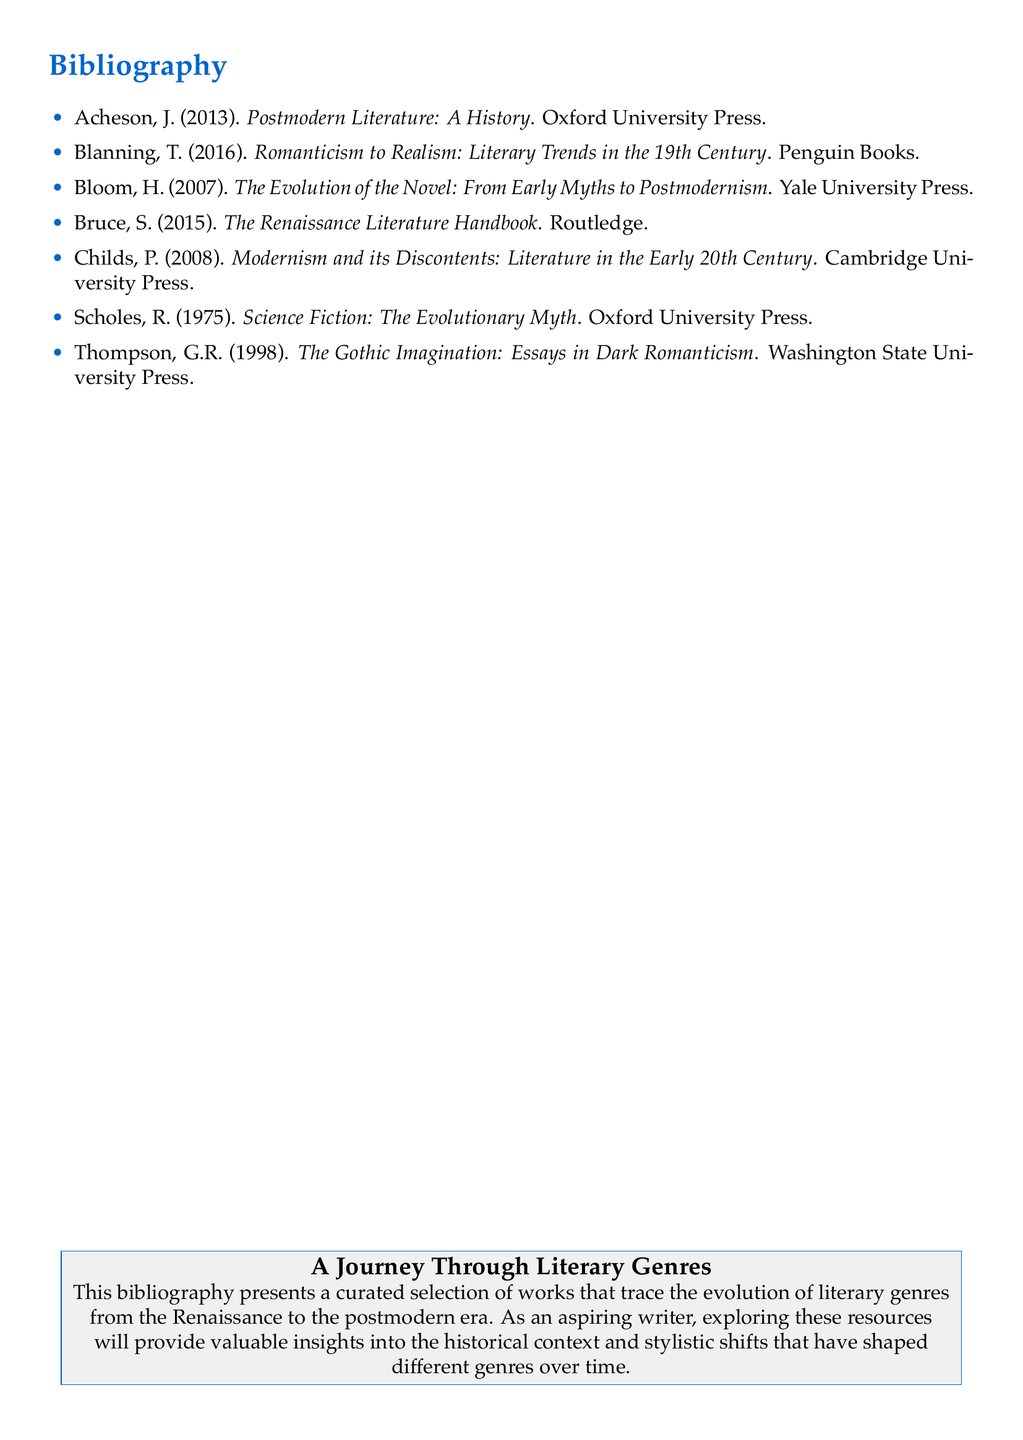What is the first author's name listed? The first author listed in the bibliography is Acheson.
Answer: Acheson How many works are cited in the bibliography? The bibliography contains a total of seven works.
Answer: 7 What is the title of Bloom's book? The title of Bloom's book is "The Evolution of the Novel: From Early Myths to Postmodernism".
Answer: The Evolution of the Novel: From Early Myths to Postmodernism Which publisher published the book "Romanticism to Realism"? The book "Romanticism to Realism" was published by Penguin Books.
Answer: Penguin Books What genre does Scholes' book focus on? Scholes' book focuses on the genre of science fiction.
Answer: Science Fiction Who is the author of "The Gothic Imagination: Essays in Dark Romanticism"? The author of this work is Thompson, G.R.
Answer: Thompson, G.R How does the bibliography describe its purpose? The bibliography describes its purpose as providing valuable insights into the historical context and stylistic shifts in literature.
Answer: Providing valuable insights into the historical context and stylistic shifts in literature What is the main theme of the bibliography? The main theme highlighted in the bibliography is the evolution of literary genres from the Renaissance to the postmodern era.
Answer: The evolution of literary genres from the Renaissance to the postmodern era 